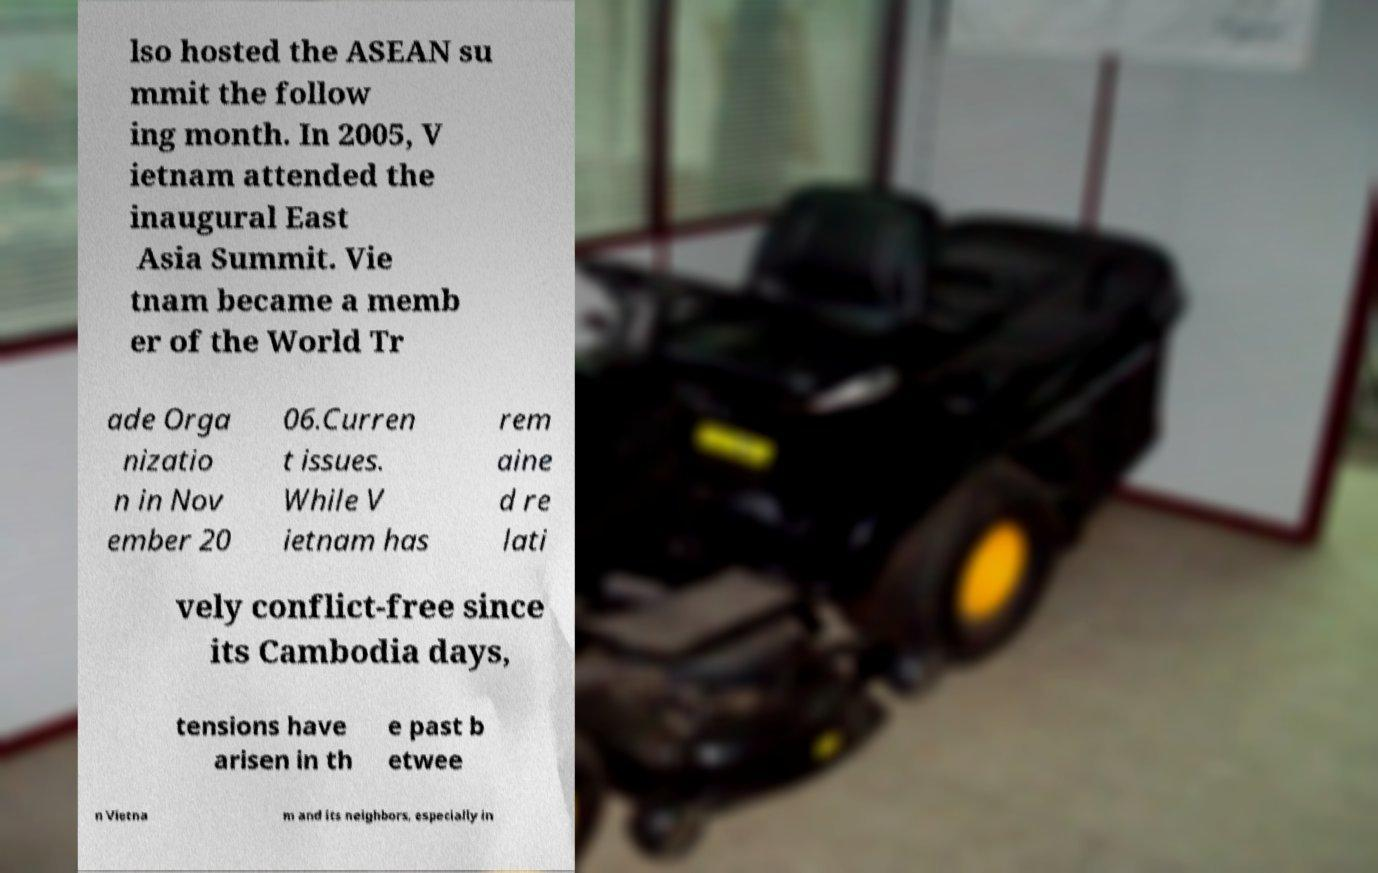Could you extract and type out the text from this image? lso hosted the ASEAN su mmit the follow ing month. In 2005, V ietnam attended the inaugural East Asia Summit. Vie tnam became a memb er of the World Tr ade Orga nizatio n in Nov ember 20 06.Curren t issues. While V ietnam has rem aine d re lati vely conflict-free since its Cambodia days, tensions have arisen in th e past b etwee n Vietna m and its neighbors, especially in 